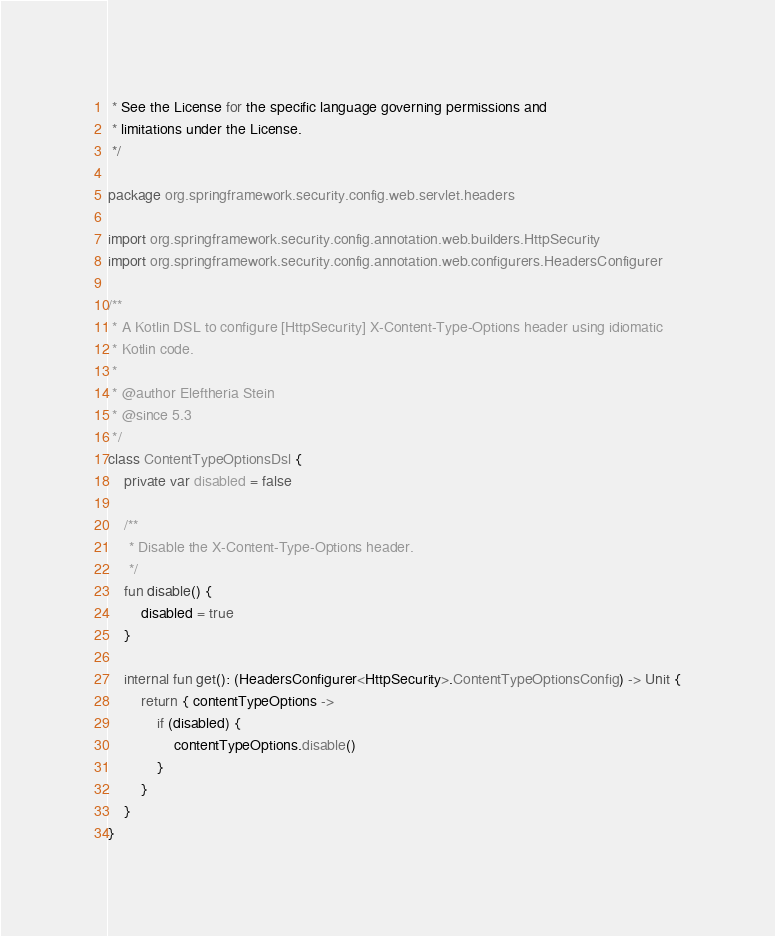<code> <loc_0><loc_0><loc_500><loc_500><_Kotlin_> * See the License for the specific language governing permissions and
 * limitations under the License.
 */

package org.springframework.security.config.web.servlet.headers

import org.springframework.security.config.annotation.web.builders.HttpSecurity
import org.springframework.security.config.annotation.web.configurers.HeadersConfigurer

/**
 * A Kotlin DSL to configure [HttpSecurity] X-Content-Type-Options header using idiomatic
 * Kotlin code.
 *
 * @author Eleftheria Stein
 * @since 5.3
 */
class ContentTypeOptionsDsl {
    private var disabled = false

    /**
     * Disable the X-Content-Type-Options header.
     */
    fun disable() {
        disabled = true
    }

    internal fun get(): (HeadersConfigurer<HttpSecurity>.ContentTypeOptionsConfig) -> Unit {
        return { contentTypeOptions ->
            if (disabled) {
                contentTypeOptions.disable()
            }
        }
    }
}
</code> 